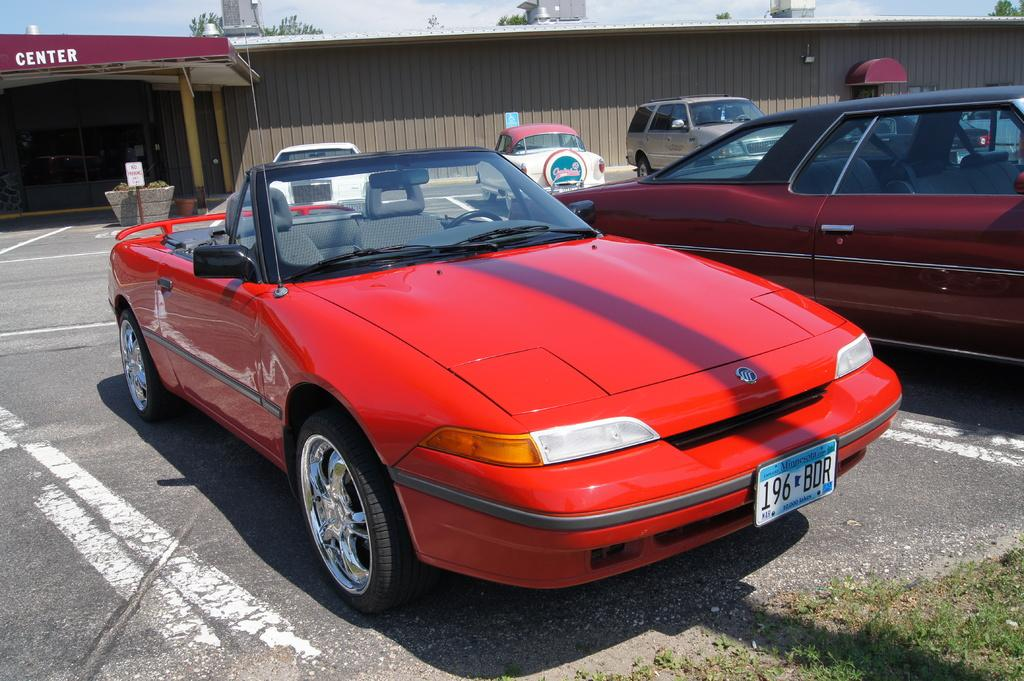Where was the image taken? The image was clicked outside. What can be seen in the middle of the image? There are cars in the middle of the image, including a red color car. What is visible at the top of the image? The sky and trees are visible at the top of the image. What type of vegetable is growing on the red car in the image? There are no vegetables growing on the red car in the image; it is a car, not a garden. 